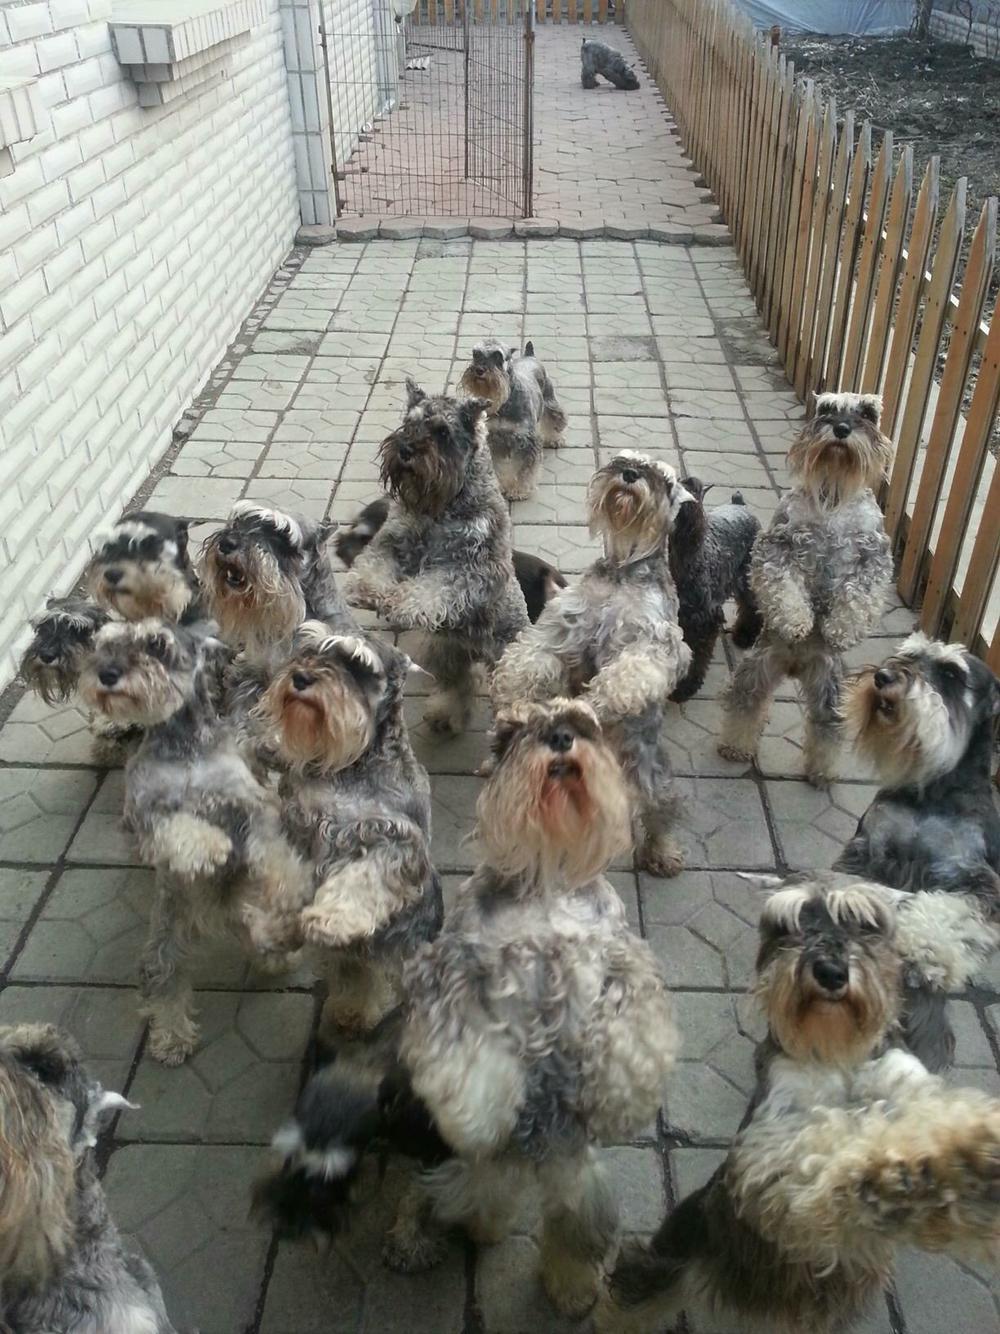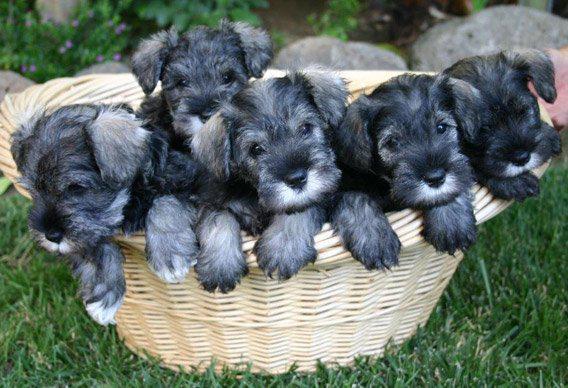The first image is the image on the left, the second image is the image on the right. Assess this claim about the two images: "There are two dogs in total.". Correct or not? Answer yes or no. No. The first image is the image on the left, the second image is the image on the right. Given the left and right images, does the statement "The right and left images contain the same number of dogs." hold true? Answer yes or no. No. 